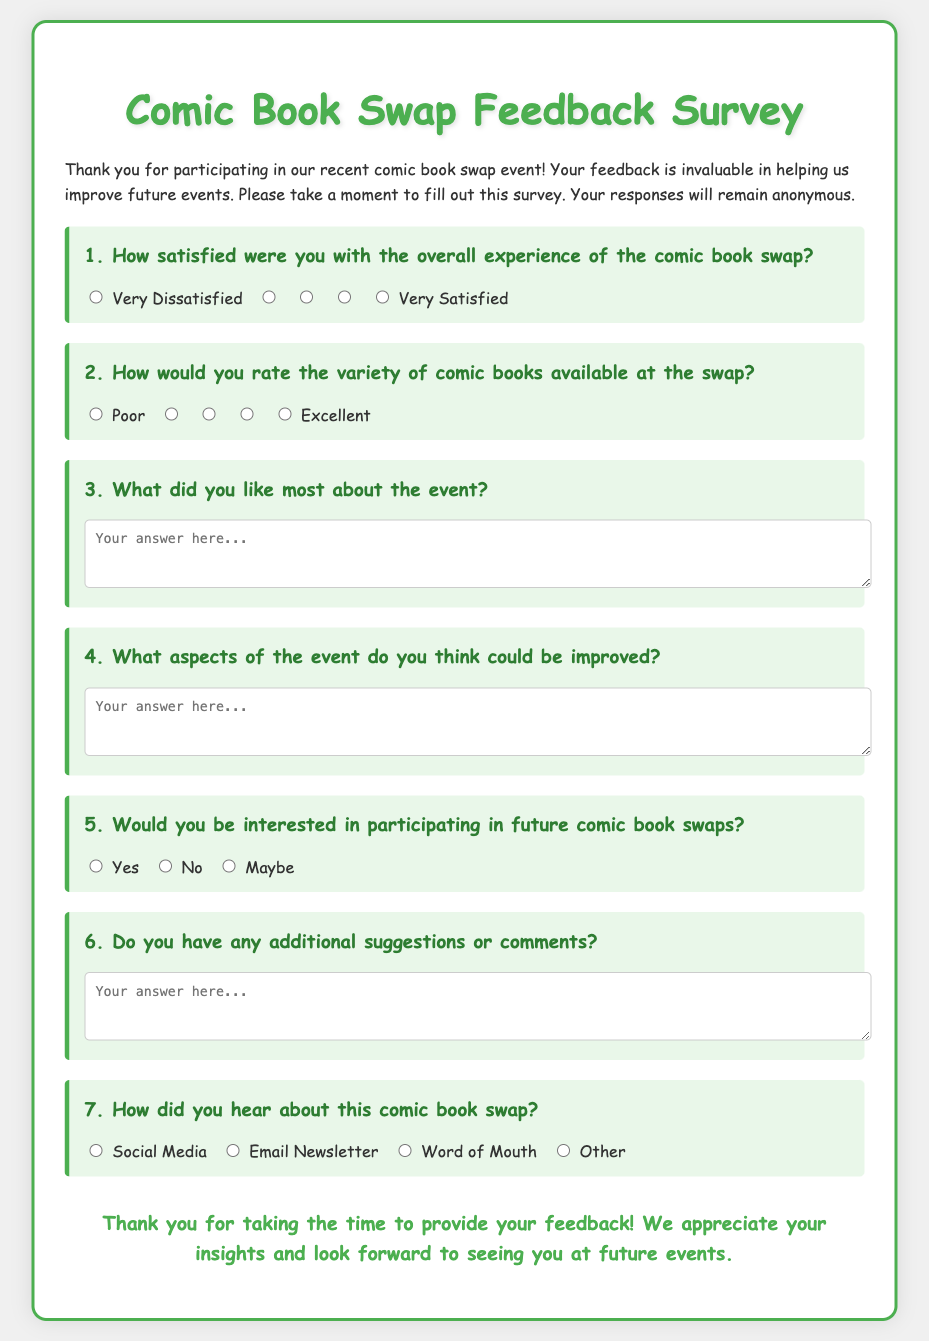What is the title of the survey? The title of the survey is prominently displayed at the top of the document, indicating the focus on feedback for a specific event.
Answer: Comic Book Swap Feedback Survey How many questions are in the survey? The survey includes a total of seven questions that participants are asked to answer.
Answer: 7 What is the highest satisfaction rating on question 1? Question 1 asks about overall experience satisfaction, and the highest rating option is indicated clearly.
Answer: Very Satisfied What feedback type is requested in question 3? Question 3 specifically asks for feedback regarding what participants liked most about the event, implying qualitative feedback.
Answer: Open-ended What options are provided for question 5 about future participation? Question 5 explores participants’ interest in future events with distinct options, summarizing potential responses.
Answer: Yes, No, Maybe Which aspect of the event could potentially be rated as "Poor"? In question 2, the rating option 'Poor' directly applies to the evaluation of comic book variety, indicating dissatisfaction.
Answer: Poor How did participants hear about the swap, according to question 7? Question 7 lists various channels through which participants could have learned about the event, indicating sources of information.
Answer: Social Media, Email Newsletter, Word of Mouth, Other 